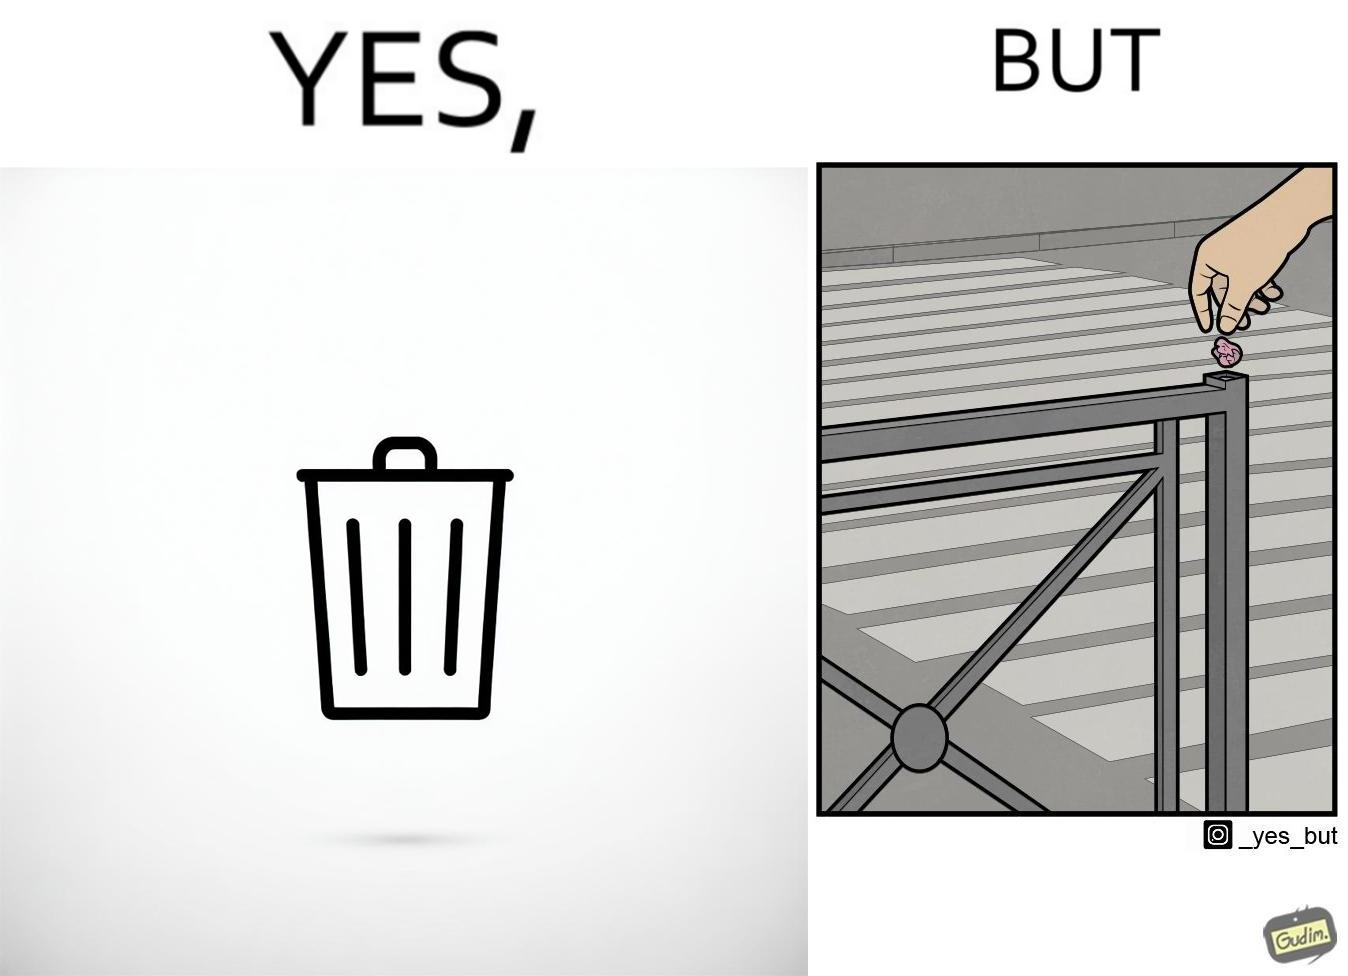Explain why this image is satirical. The images are ironic because even though garbage bins are provided for humans to dispose waste, by habit humans still choose to make surroundings dirty by disposing garbage improperly 